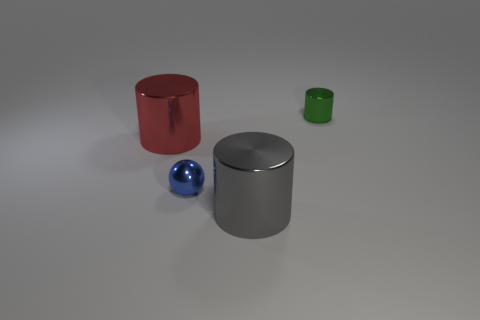How many red objects have the same shape as the small blue metallic object?
Offer a very short reply. 0. What number of tiny purple rubber things are there?
Ensure brevity in your answer.  0. There is a tiny green shiny thing; does it have the same shape as the tiny object on the left side of the large gray thing?
Provide a succinct answer. No. How many things are either big brown objects or tiny blue things that are on the right side of the red metallic cylinder?
Provide a short and direct response. 1. Does the tiny object behind the large red thing have the same shape as the red metal object?
Provide a succinct answer. Yes. Is the number of tiny objects that are on the right side of the large red cylinder less than the number of metal objects that are behind the gray cylinder?
Your response must be concise. Yes. How many other things are there of the same shape as the big gray metallic thing?
Ensure brevity in your answer.  2. There is a metal cylinder that is right of the large shiny object that is on the right side of the tiny object in front of the small green shiny thing; what is its size?
Your answer should be compact. Small. How many gray things are cylinders or shiny balls?
Keep it short and to the point. 1. What shape is the small metallic thing that is behind the big metal cylinder behind the big gray object?
Provide a succinct answer. Cylinder. 